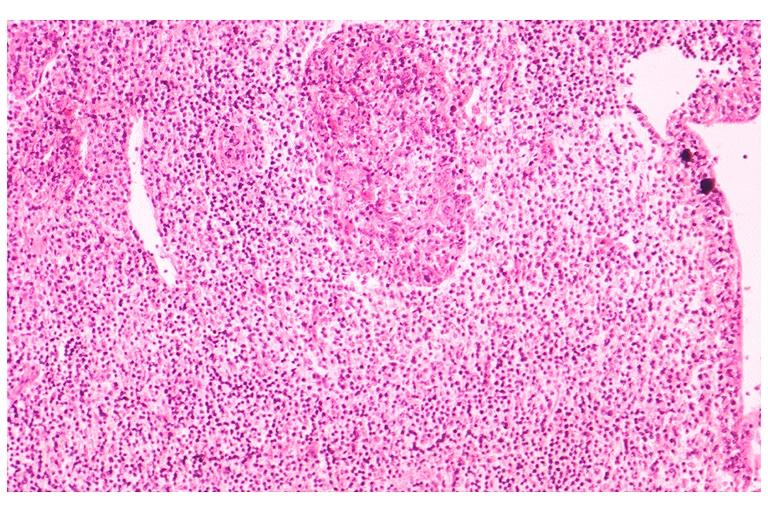where is this?
Answer the question using a single word or phrase. Oral 